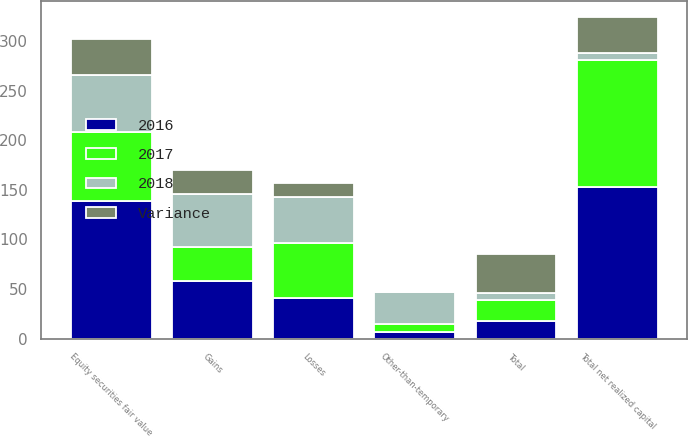Convert chart. <chart><loc_0><loc_0><loc_500><loc_500><stacked_bar_chart><ecel><fcel>Gains<fcel>Losses<fcel>Total<fcel>Other-than-temporary<fcel>Equity securities fair value<fcel>Total net realized capital<nl><fcel>2017<fcel>34<fcel>55.7<fcel>21.7<fcel>8.1<fcel>68.8<fcel>127.1<nl><fcel>2016<fcel>58.6<fcel>40.9<fcel>17.7<fcel>7.1<fcel>139<fcel>153.2<nl><fcel>2018<fcel>52.8<fcel>45.9<fcel>6.9<fcel>31.6<fcel>57.7<fcel>7.2<nl><fcel>Variance<fcel>24.6<fcel>14.8<fcel>39.4<fcel>1<fcel>36.7<fcel>36.7<nl></chart> 